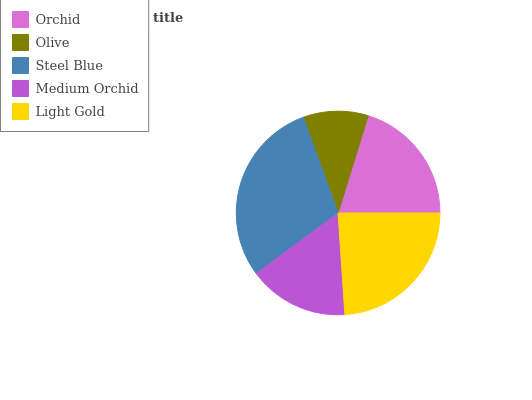Is Olive the minimum?
Answer yes or no. Yes. Is Steel Blue the maximum?
Answer yes or no. Yes. Is Steel Blue the minimum?
Answer yes or no. No. Is Olive the maximum?
Answer yes or no. No. Is Steel Blue greater than Olive?
Answer yes or no. Yes. Is Olive less than Steel Blue?
Answer yes or no. Yes. Is Olive greater than Steel Blue?
Answer yes or no. No. Is Steel Blue less than Olive?
Answer yes or no. No. Is Orchid the high median?
Answer yes or no. Yes. Is Orchid the low median?
Answer yes or no. Yes. Is Steel Blue the high median?
Answer yes or no. No. Is Medium Orchid the low median?
Answer yes or no. No. 